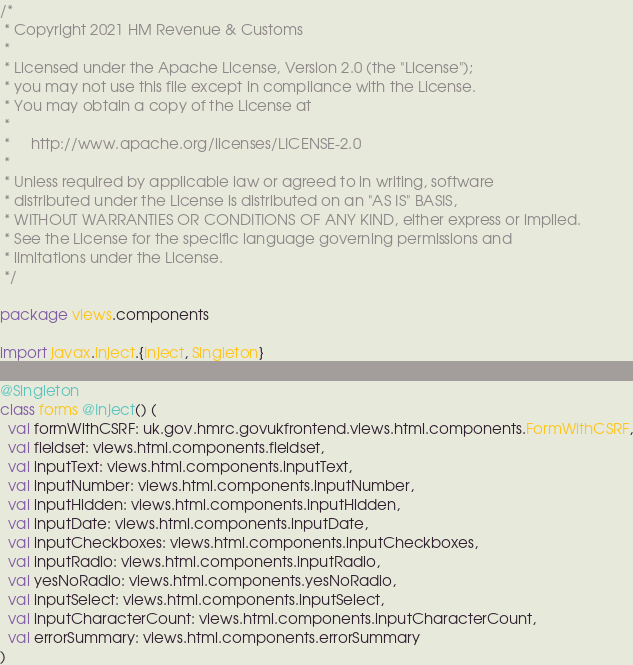Convert code to text. <code><loc_0><loc_0><loc_500><loc_500><_Scala_>/*
 * Copyright 2021 HM Revenue & Customs
 *
 * Licensed under the Apache License, Version 2.0 (the "License");
 * you may not use this file except in compliance with the License.
 * You may obtain a copy of the License at
 *
 *     http://www.apache.org/licenses/LICENSE-2.0
 *
 * Unless required by applicable law or agreed to in writing, software
 * distributed under the License is distributed on an "AS IS" BASIS,
 * WITHOUT WARRANTIES OR CONDITIONS OF ANY KIND, either express or implied.
 * See the License for the specific language governing permissions and
 * limitations under the License.
 */

package views.components

import javax.inject.{Inject, Singleton}

@Singleton
class forms @Inject() (
  val formWithCSRF: uk.gov.hmrc.govukfrontend.views.html.components.FormWithCSRF,
  val fieldset: views.html.components.fieldset,
  val inputText: views.html.components.inputText,
  val inputNumber: views.html.components.inputNumber,
  val inputHidden: views.html.components.inputHidden,
  val inputDate: views.html.components.inputDate,
  val inputCheckboxes: views.html.components.inputCheckboxes,
  val inputRadio: views.html.components.inputRadio,
  val yesNoRadio: views.html.components.yesNoRadio,
  val inputSelect: views.html.components.inputSelect,
  val inputCharacterCount: views.html.components.inputCharacterCount,
  val errorSummary: views.html.components.errorSummary
)
</code> 